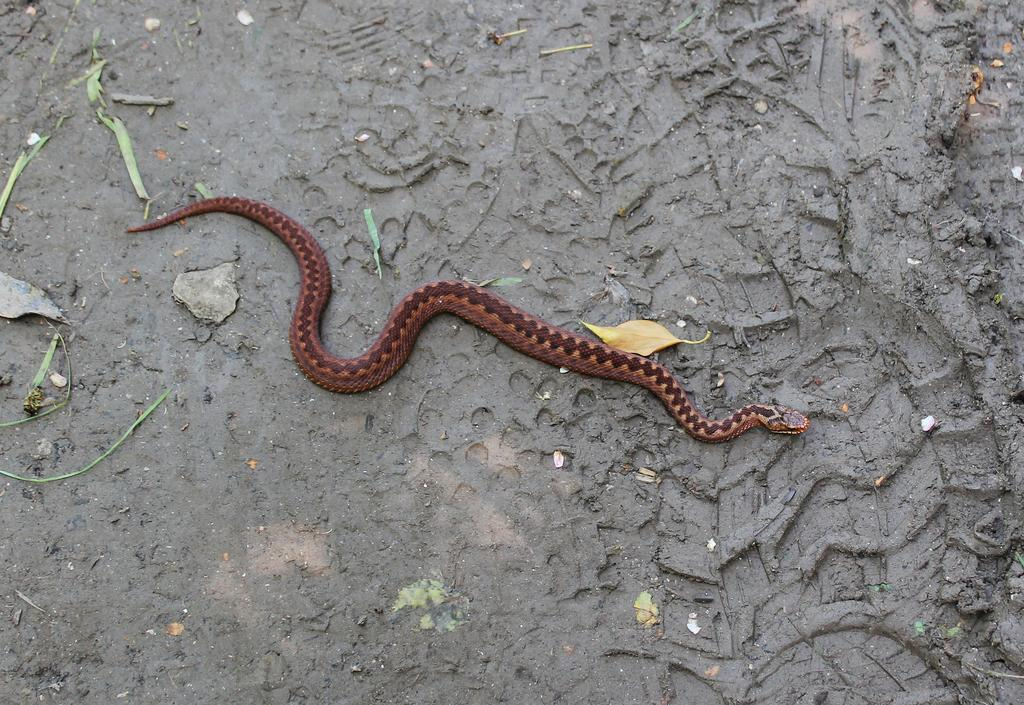What animal is present in the image? There is a snake in the image. What color is the snake? The snake is brown in color. What is the snake resting on in the image? The snake is on a grey surface. What numerical value does the snake represent in the image? The snake does not represent a numerical value in the image; it is a living creature. 